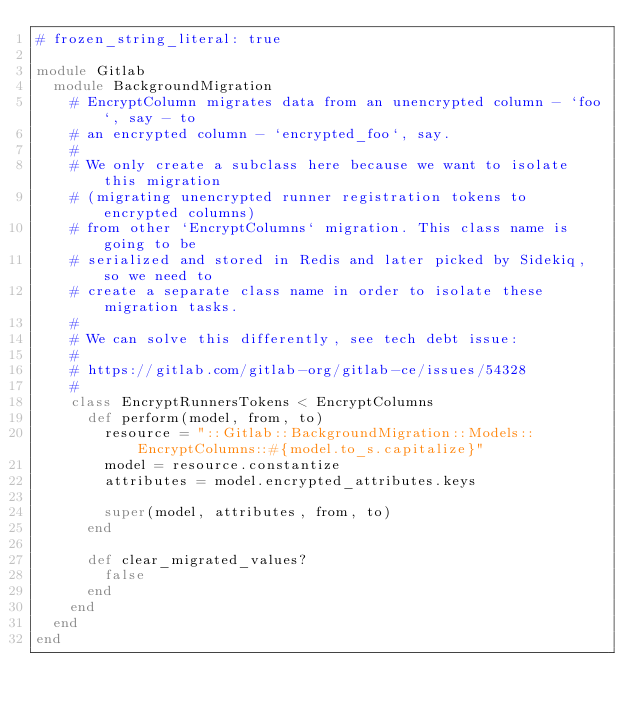Convert code to text. <code><loc_0><loc_0><loc_500><loc_500><_Ruby_># frozen_string_literal: true

module Gitlab
  module BackgroundMigration
    # EncryptColumn migrates data from an unencrypted column - `foo`, say - to
    # an encrypted column - `encrypted_foo`, say.
    #
    # We only create a subclass here because we want to isolate this migration
    # (migrating unencrypted runner registration tokens to encrypted columns)
    # from other `EncryptColumns` migration. This class name is going to be
    # serialized and stored in Redis and later picked by Sidekiq, so we need to
    # create a separate class name in order to isolate these migration tasks.
    #
    # We can solve this differently, see tech debt issue:
    #
    # https://gitlab.com/gitlab-org/gitlab-ce/issues/54328
    #
    class EncryptRunnersTokens < EncryptColumns
      def perform(model, from, to)
        resource = "::Gitlab::BackgroundMigration::Models::EncryptColumns::#{model.to_s.capitalize}"
        model = resource.constantize
        attributes = model.encrypted_attributes.keys

        super(model, attributes, from, to)
      end

      def clear_migrated_values?
        false
      end
    end
  end
end
</code> 